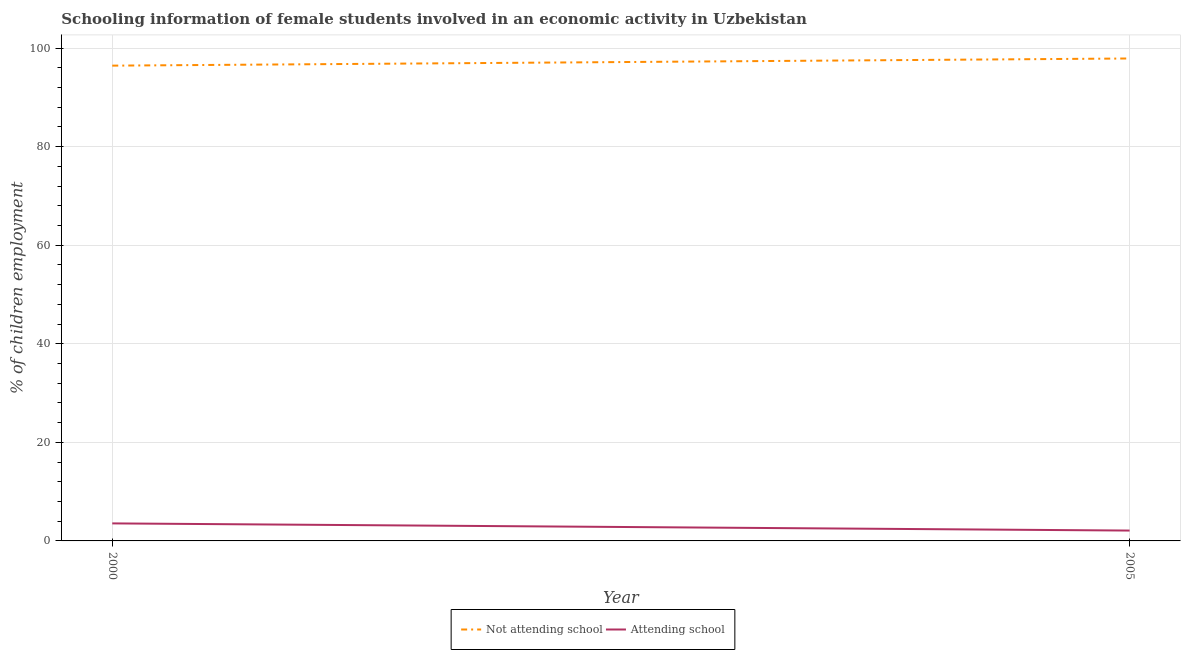Is the number of lines equal to the number of legend labels?
Provide a short and direct response. Yes. Across all years, what is the maximum percentage of employed females who are not attending school?
Give a very brief answer. 97.9. Across all years, what is the minimum percentage of employed females who are attending school?
Provide a succinct answer. 2.1. In which year was the percentage of employed females who are not attending school minimum?
Offer a terse response. 2000. What is the total percentage of employed females who are not attending school in the graph?
Give a very brief answer. 194.35. What is the difference between the percentage of employed females who are attending school in 2000 and that in 2005?
Give a very brief answer. 1.45. What is the difference between the percentage of employed females who are attending school in 2005 and the percentage of employed females who are not attending school in 2000?
Keep it short and to the point. -94.35. What is the average percentage of employed females who are attending school per year?
Give a very brief answer. 2.83. In the year 2005, what is the difference between the percentage of employed females who are not attending school and percentage of employed females who are attending school?
Give a very brief answer. 95.8. In how many years, is the percentage of employed females who are attending school greater than 84 %?
Offer a terse response. 0. What is the ratio of the percentage of employed females who are not attending school in 2000 to that in 2005?
Make the answer very short. 0.99. Is the percentage of employed females who are attending school in 2000 less than that in 2005?
Ensure brevity in your answer.  No. In how many years, is the percentage of employed females who are attending school greater than the average percentage of employed females who are attending school taken over all years?
Your answer should be very brief. 1. Is the percentage of employed females who are attending school strictly greater than the percentage of employed females who are not attending school over the years?
Offer a very short reply. No. What is the difference between two consecutive major ticks on the Y-axis?
Your answer should be compact. 20. Are the values on the major ticks of Y-axis written in scientific E-notation?
Your answer should be compact. No. Does the graph contain grids?
Keep it short and to the point. Yes. How are the legend labels stacked?
Offer a terse response. Horizontal. What is the title of the graph?
Provide a succinct answer. Schooling information of female students involved in an economic activity in Uzbekistan. What is the label or title of the Y-axis?
Offer a terse response. % of children employment. What is the % of children employment of Not attending school in 2000?
Offer a very short reply. 96.45. What is the % of children employment of Attending school in 2000?
Keep it short and to the point. 3.55. What is the % of children employment in Not attending school in 2005?
Provide a succinct answer. 97.9. What is the % of children employment in Attending school in 2005?
Offer a very short reply. 2.1. Across all years, what is the maximum % of children employment of Not attending school?
Ensure brevity in your answer.  97.9. Across all years, what is the maximum % of children employment in Attending school?
Keep it short and to the point. 3.55. Across all years, what is the minimum % of children employment of Not attending school?
Keep it short and to the point. 96.45. What is the total % of children employment in Not attending school in the graph?
Make the answer very short. 194.35. What is the total % of children employment in Attending school in the graph?
Your answer should be compact. 5.65. What is the difference between the % of children employment in Not attending school in 2000 and that in 2005?
Your answer should be compact. -1.45. What is the difference between the % of children employment of Attending school in 2000 and that in 2005?
Provide a succinct answer. 1.45. What is the difference between the % of children employment in Not attending school in 2000 and the % of children employment in Attending school in 2005?
Give a very brief answer. 94.35. What is the average % of children employment in Not attending school per year?
Make the answer very short. 97.17. What is the average % of children employment in Attending school per year?
Your answer should be compact. 2.83. In the year 2000, what is the difference between the % of children employment of Not attending school and % of children employment of Attending school?
Give a very brief answer. 92.89. In the year 2005, what is the difference between the % of children employment in Not attending school and % of children employment in Attending school?
Ensure brevity in your answer.  95.8. What is the ratio of the % of children employment of Not attending school in 2000 to that in 2005?
Give a very brief answer. 0.99. What is the ratio of the % of children employment in Attending school in 2000 to that in 2005?
Keep it short and to the point. 1.69. What is the difference between the highest and the second highest % of children employment in Not attending school?
Provide a short and direct response. 1.45. What is the difference between the highest and the second highest % of children employment in Attending school?
Your response must be concise. 1.45. What is the difference between the highest and the lowest % of children employment of Not attending school?
Provide a short and direct response. 1.45. What is the difference between the highest and the lowest % of children employment in Attending school?
Ensure brevity in your answer.  1.45. 